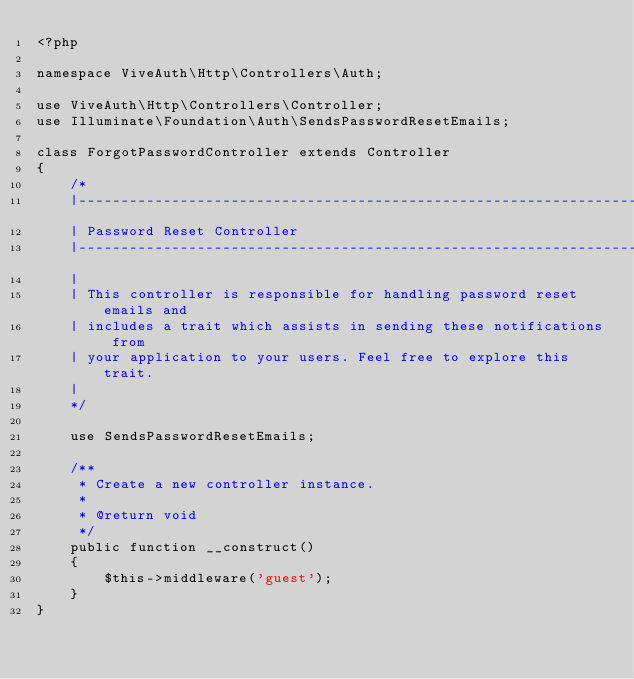Convert code to text. <code><loc_0><loc_0><loc_500><loc_500><_PHP_><?php

namespace ViveAuth\Http\Controllers\Auth;

use ViveAuth\Http\Controllers\Controller;
use Illuminate\Foundation\Auth\SendsPasswordResetEmails;

class ForgotPasswordController extends Controller
{
    /*
    |--------------------------------------------------------------------------
    | Password Reset Controller
    |--------------------------------------------------------------------------
    |
    | This controller is responsible for handling password reset emails and
    | includes a trait which assists in sending these notifications from
    | your application to your users. Feel free to explore this trait.
    |
    */

    use SendsPasswordResetEmails;

    /**
     * Create a new controller instance.
     *
     * @return void
     */
    public function __construct()
    {
        $this->middleware('guest');
    }
}
</code> 